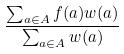Convert formula to latex. <formula><loc_0><loc_0><loc_500><loc_500>\frac { \sum _ { a \in A } f ( a ) w ( a ) } { \sum _ { a \in A } w ( a ) }</formula> 